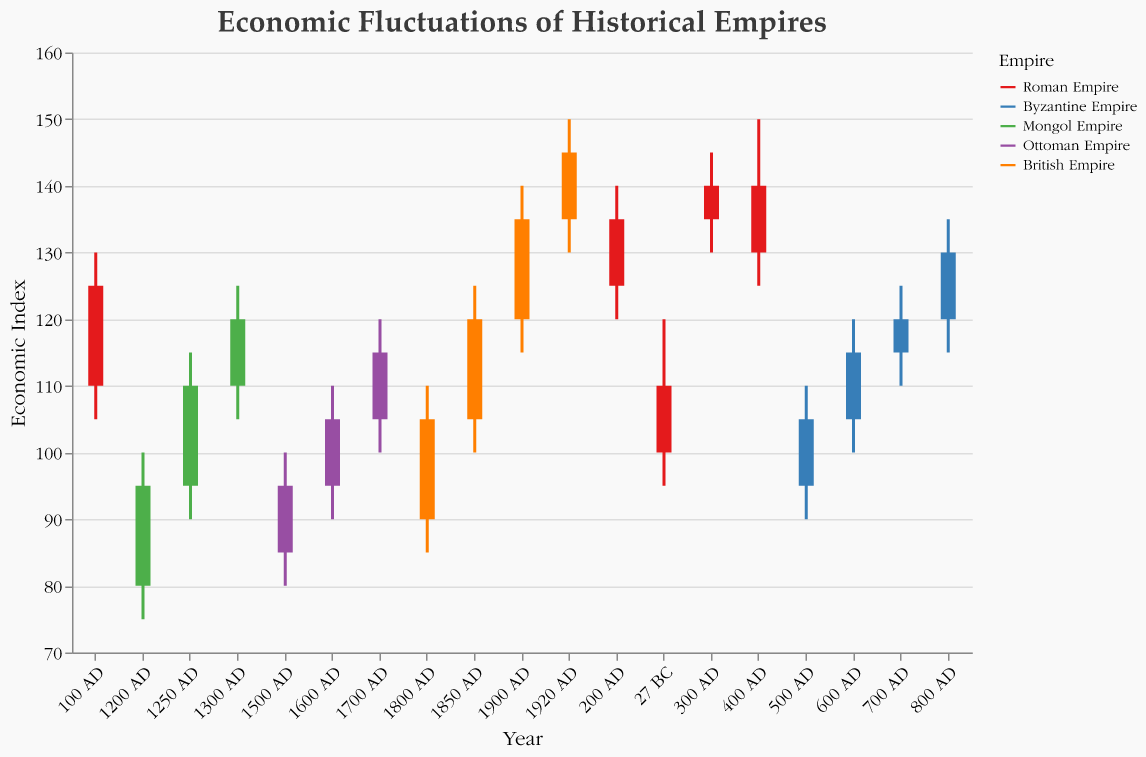What is the title of the chart? The title is displayed at the top of the chart. It reads "Economic Fluctuations of Historical Empires."
Answer: Economic Fluctuations of Historical Empires What is the economic index range for the Roman Empire in 400 AD? The economic index is shown through the 'High' and 'Low' values on the Y-axis. For 400 AD, the values are from 125 to 150.
Answer: 125 to 150 Which empire had the highest economic index close value in the data provided? By examining the 'Close' values for each empire, the highest is 145 for the British Empire in 1920 AD.
Answer: British Empire How did the British Empire's economic index change from 1800 AD to 1850 AD? The 'Close' value for 1800 AD is 105 and for 1850 AD is 120, so it increased by 15.
Answer: Increased by 15 What is the difference between the highest and lowest economic index for the Byzantine Empire in 700 AD? The 'High' value is 125 and the 'Low' value is 110, giving a difference of 15.
Answer: 15 Which two periods have the greatest difference in 'High' economic index values for the Mongol Empire? The 'High' values for the Mongol Empire are 100 (1200 AD), 115 (1250 AD), and 125 (1300 AD). The greatest difference is between 1200 AD and 1300 AD, which is 25.
Answer: 1200 AD and 1300 AD How does the economic closing value of the Byzantine Empire in 500 AD compare to the Roman Empire in 27 BC? The 'Close' value for the Byzantine Empire in 500 AD is 105, whereas for the Roman Empire in 27 BC it is 110. The Byzantine Empire's value is 5 units lower.
Answer: 5 units lower What is the average 'Close' value for the Ottoman Empire across all provided periods? The 'Close' values for the Ottoman Empire are 95, 105, and 115. The average is (95 + 105 + 115)/3 = 105.
Answer: 105 